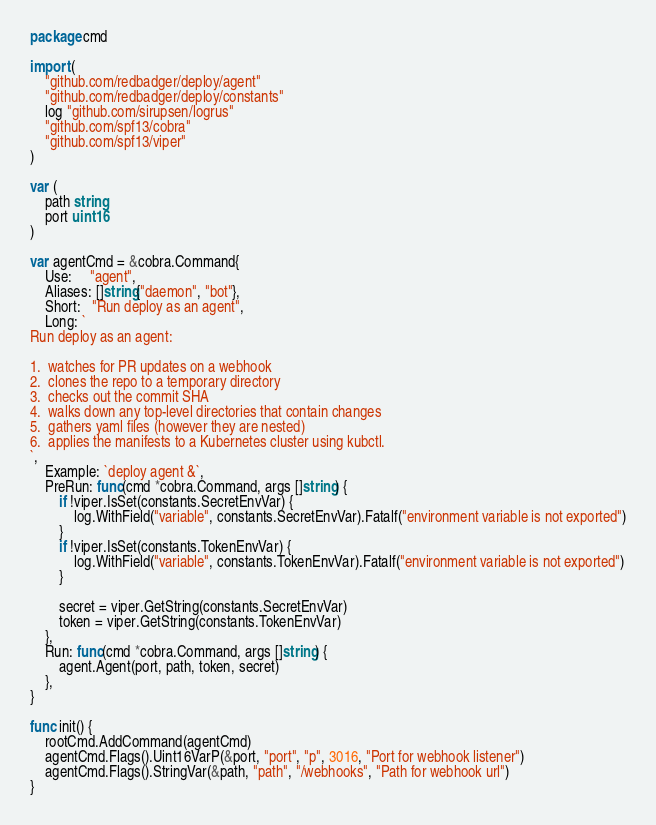<code> <loc_0><loc_0><loc_500><loc_500><_Go_>package cmd

import (
	"github.com/redbadger/deploy/agent"
	"github.com/redbadger/deploy/constants"
	log "github.com/sirupsen/logrus"
	"github.com/spf13/cobra"
	"github.com/spf13/viper"
)

var (
	path string
	port uint16
)

var agentCmd = &cobra.Command{
	Use:     "agent",
	Aliases: []string{"daemon", "bot"},
	Short:   "Run deploy as an agent",
	Long: `
Run deploy as an agent:

1.  watches for PR updates on a webhook
2.  clones the repo to a temporary directory
3.  checks out the commit SHA
4.  walks down any top-level directories that contain changes
5.  gathers yaml files (however they are nested)
6.  applies the manifests to a Kubernetes cluster using kubctl.
`,
	Example: `deploy agent &`,
	PreRun: func(cmd *cobra.Command, args []string) {
		if !viper.IsSet(constants.SecretEnvVar) {
			log.WithField("variable", constants.SecretEnvVar).Fatalf("environment variable is not exported")
		}
		if !viper.IsSet(constants.TokenEnvVar) {
			log.WithField("variable", constants.TokenEnvVar).Fatalf("environment variable is not exported")
		}

		secret = viper.GetString(constants.SecretEnvVar)
		token = viper.GetString(constants.TokenEnvVar)
	},
	Run: func(cmd *cobra.Command, args []string) {
		agent.Agent(port, path, token, secret)
	},
}

func init() {
	rootCmd.AddCommand(agentCmd)
	agentCmd.Flags().Uint16VarP(&port, "port", "p", 3016, "Port for webhook listener")
	agentCmd.Flags().StringVar(&path, "path", "/webhooks", "Path for webhook url")
}
</code> 